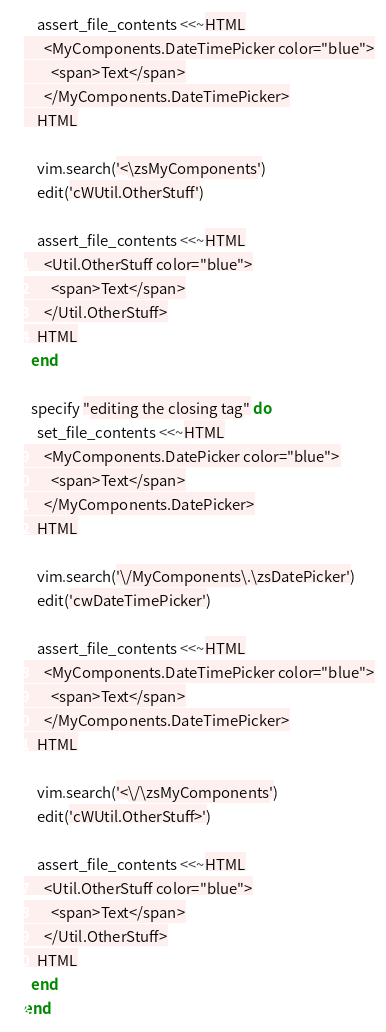Convert code to text. <code><loc_0><loc_0><loc_500><loc_500><_Ruby_>    assert_file_contents <<~HTML
      <MyComponents.DateTimePicker color="blue">
        <span>Text</span>
      </MyComponents.DateTimePicker>
    HTML

    vim.search('<\zsMyComponents')
    edit('cWUtil.OtherStuff')

    assert_file_contents <<~HTML
      <Util.OtherStuff color="blue">
        <span>Text</span>
      </Util.OtherStuff>
    HTML
  end

  specify "editing the closing tag" do
    set_file_contents <<~HTML
      <MyComponents.DatePicker color="blue">
        <span>Text</span>
      </MyComponents.DatePicker>
    HTML

    vim.search('\/MyComponents\.\zsDatePicker')
    edit('cwDateTimePicker')

    assert_file_contents <<~HTML
      <MyComponents.DateTimePicker color="blue">
        <span>Text</span>
      </MyComponents.DateTimePicker>
    HTML

    vim.search('<\/\zsMyComponents')
    edit('cWUtil.OtherStuff>')

    assert_file_contents <<~HTML
      <Util.OtherStuff color="blue">
        <span>Text</span>
      </Util.OtherStuff>
    HTML
  end
end
</code> 